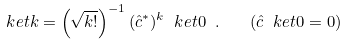<formula> <loc_0><loc_0><loc_500><loc_500>\ k e t { k } = \left ( \sqrt { k ! } \right ) ^ { - 1 } ( { \hat { c } } ^ { * } ) ^ { k } \ k e t { 0 } \ . \quad ( { \hat { c } } \ k e t { 0 } = 0 )</formula> 